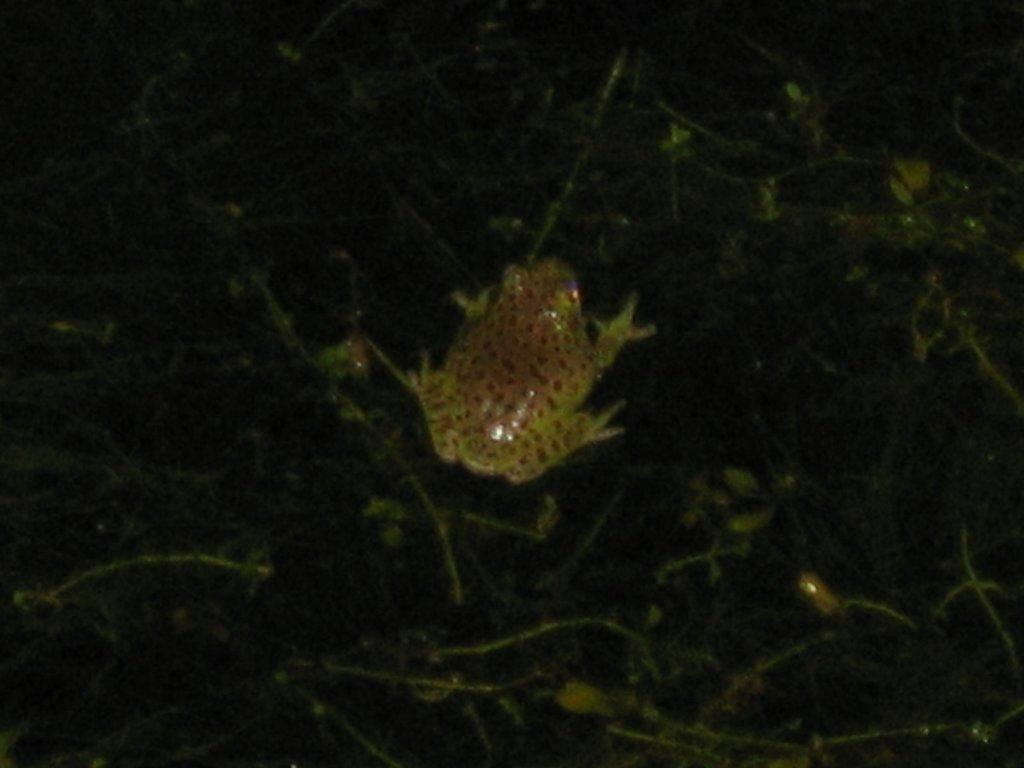What type of animal is in the image? There is a frog in the image. What colors can be seen on the frog? The frog has brown and yellow colors. What is the background or surface that the frog is on? The frog is on a black and green color surface. What type of produce is being harvested in the image? There is no produce or harvesting activity present in the image; it features a frog on a black and green surface. 